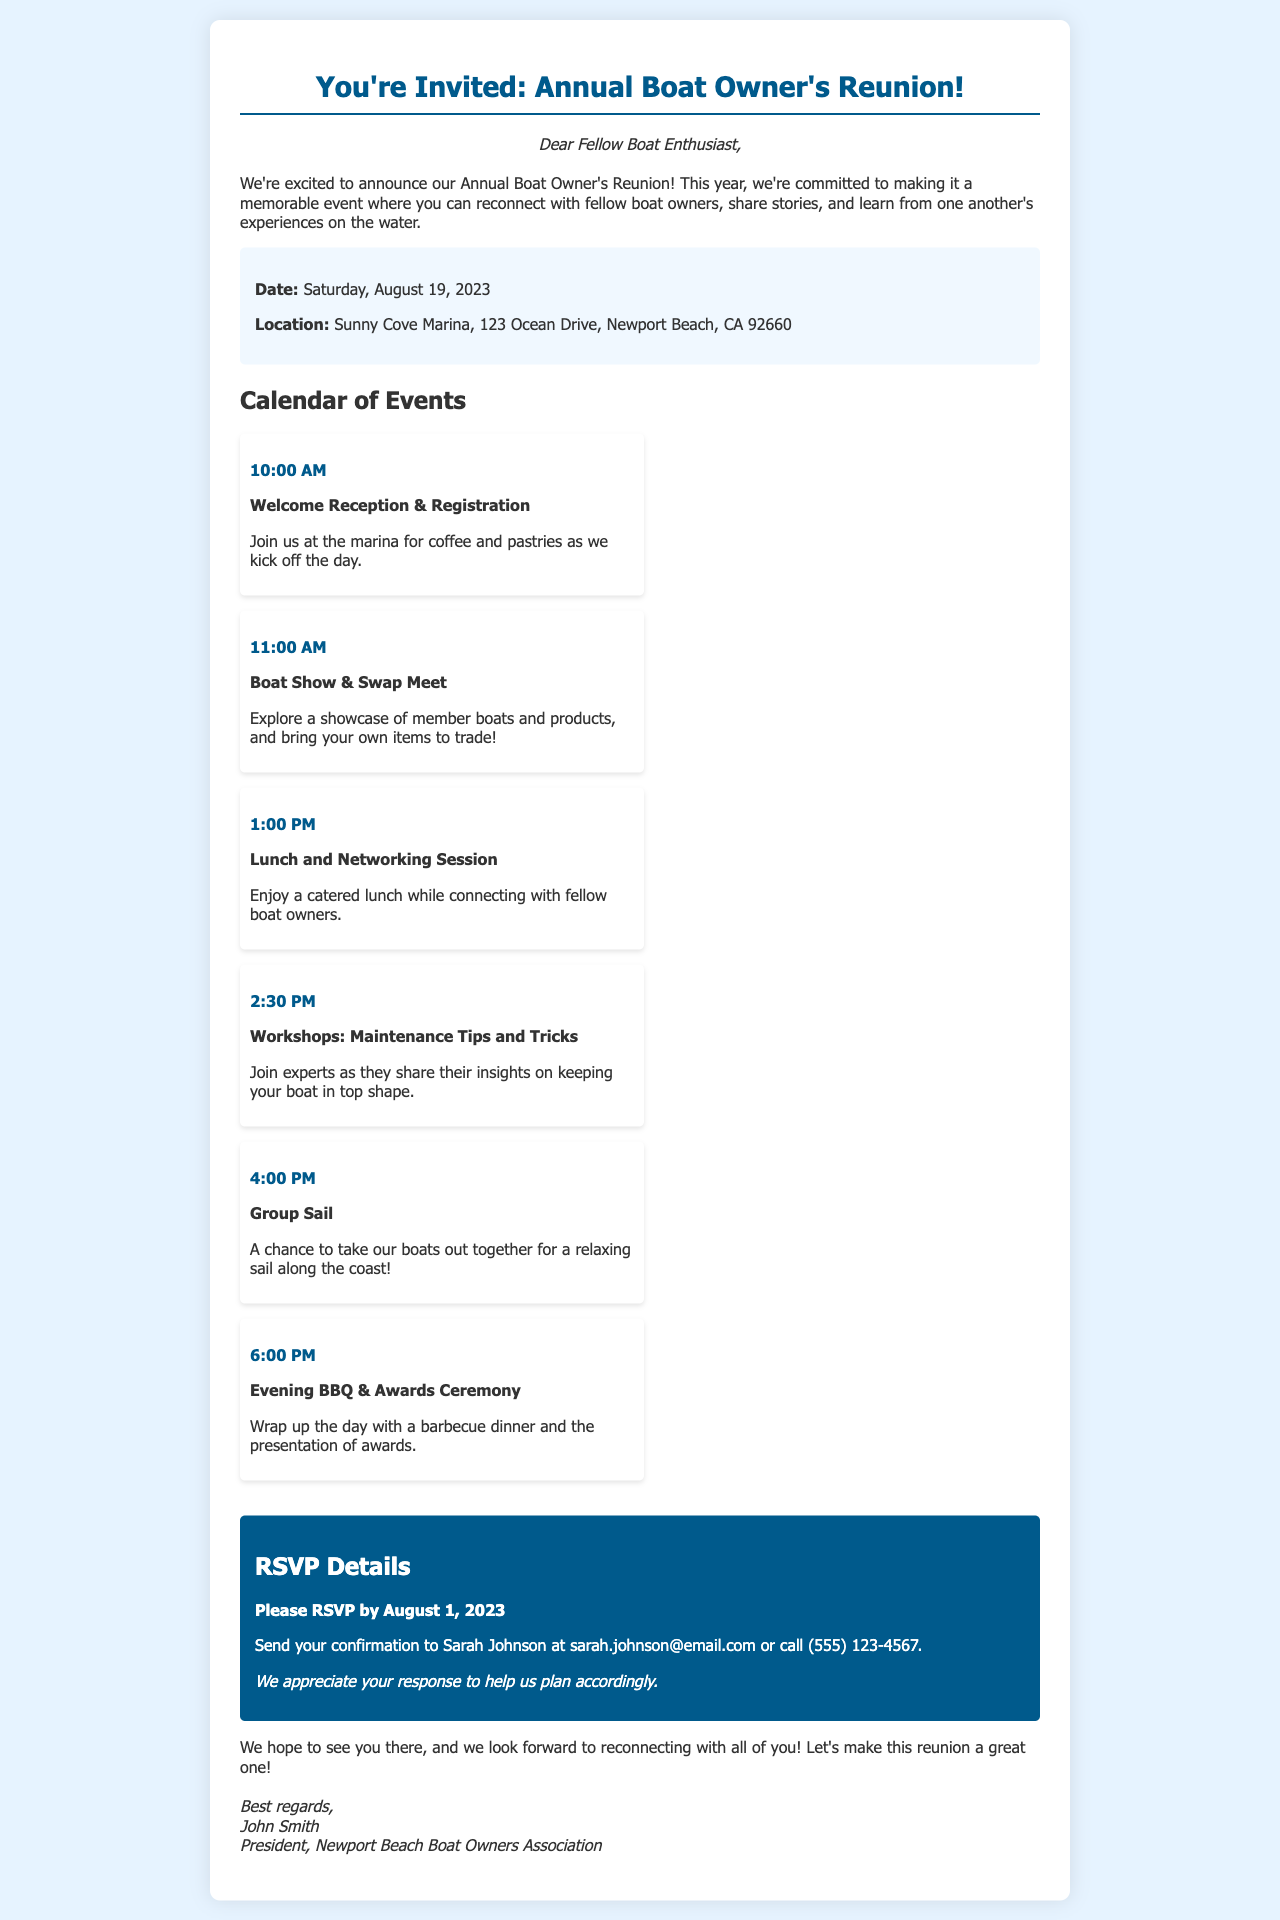What is the date of the reunion? The date is explicitly mentioned in the document as Saturday, August 19, 2023.
Answer: Saturday, August 19, 2023 Where is the reunion being held? The location is listed in the document as Sunny Cove Marina, 123 Ocean Drive, Newport Beach, CA 92660.
Answer: Sunny Cove Marina, 123 Ocean Drive, Newport Beach, CA 92660 What time does the welcome reception start? The specific start time for the welcome reception is stated as 10:00 AM.
Answer: 10:00 AM Who should the RSVP be sent to? The document specifies that confirmations should be sent to Sarah Johnson.
Answer: Sarah Johnson What is the deadline for RSVP? The deadline for RSVP is clearly stated in the document as August 1, 2023.
Answer: August 1, 2023 What type of event begins at 1:00 PM? The document lists a Lunch and Networking Session starting at 1:00 PM.
Answer: Lunch and Networking Session Why is the reunion important for boat owners? The document mentions it is an opportunity to reconnect, share stories, and learn from fellow boat owners.
Answer: Reconnect, share stories, learn What is the final event of the day? The last event mentioned is the Evening BBQ & Awards Ceremony at 6:00 PM.
Answer: Evening BBQ & Awards Ceremony 